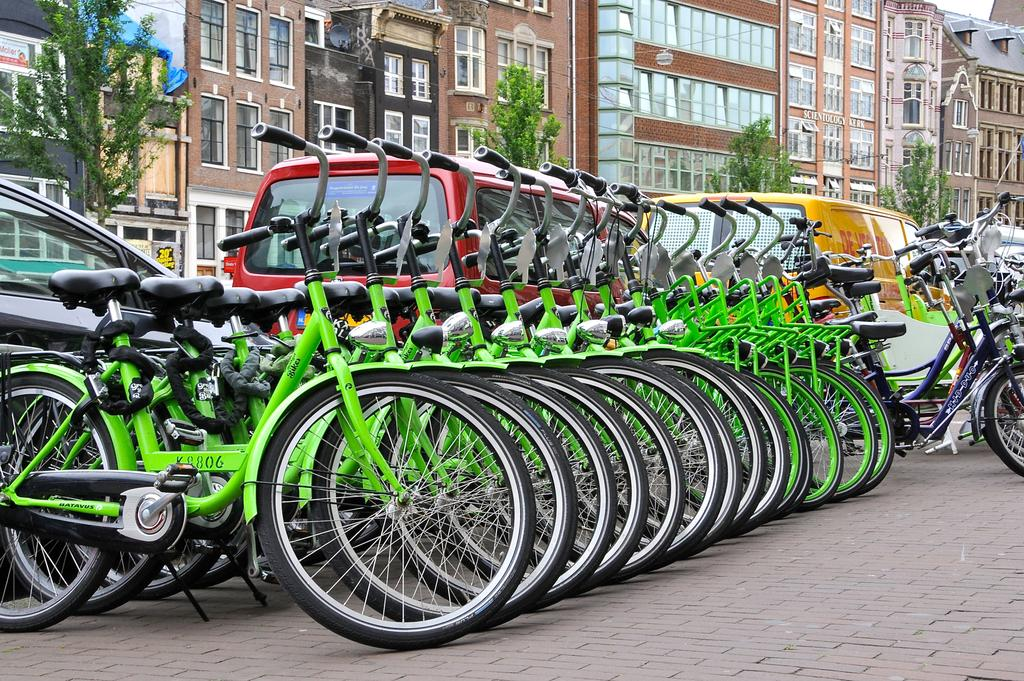What type of vehicles are parked on the path in the image? There are cycles parked on a path in the image. What is located behind the cycles? There are vehicles behind the cycles. What can be seen in the distance in the image? There are trees and buildings in the background of the image. What type of vest is being used to cover the cycles in the image? There is no vest present in the image, and the cycles are not covered. What quilt is being used to decorate the vehicles behind the cycles? There is no quilt present in the image; the vehicles are not decorated with a quilt. 